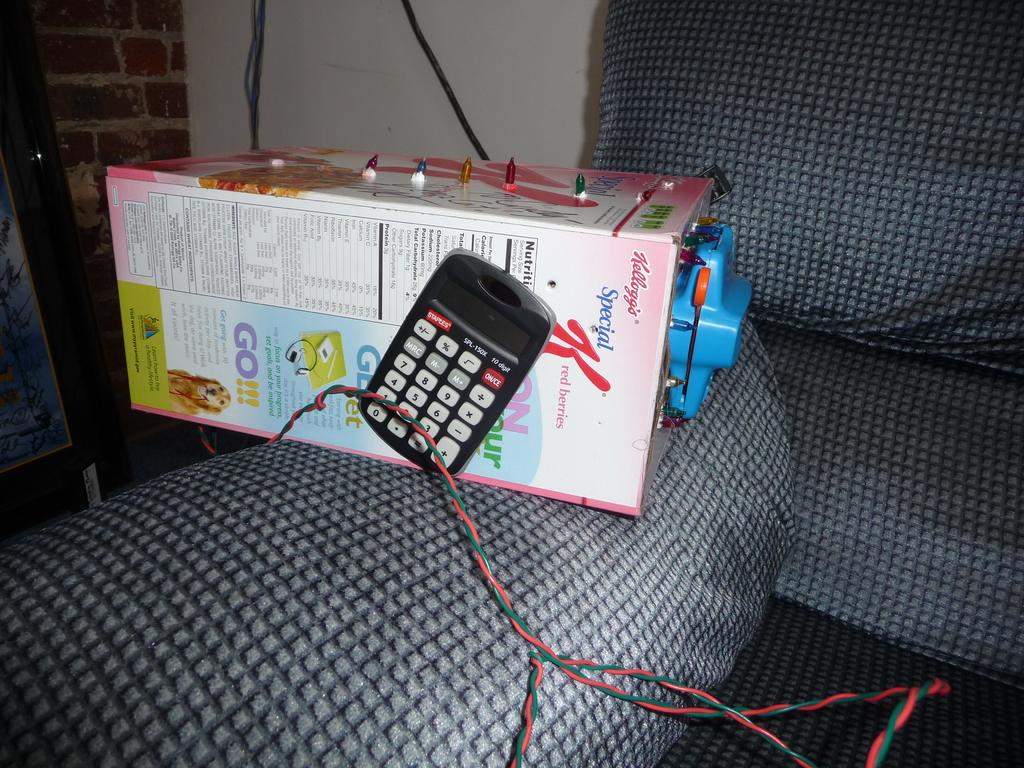What is on the sofa in the image? There is an object on the sofa in the image. What can be seen in the background of the image? There is a wall in the background of the image. What type of object is on the left side of the image? There is a wooden object on the left side of the image. Who is giving a birthday kiss to the authority figure in the image? There is no birthday, kiss, or authority figure present in the image. 